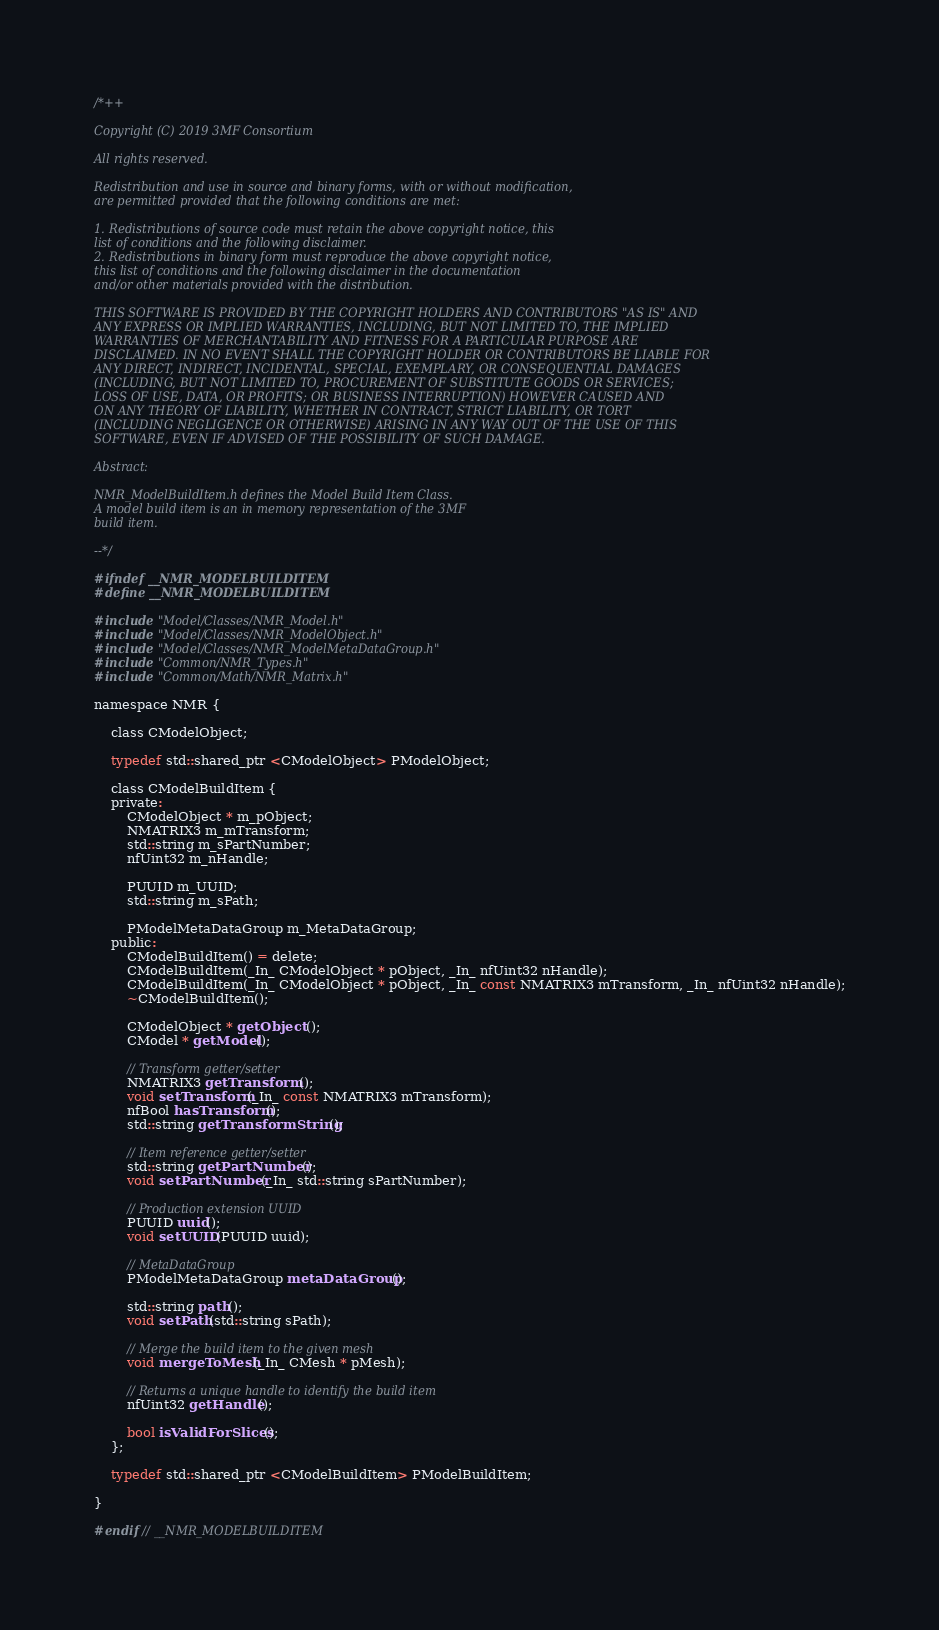<code> <loc_0><loc_0><loc_500><loc_500><_C_>/*++

Copyright (C) 2019 3MF Consortium

All rights reserved.

Redistribution and use in source and binary forms, with or without modification,
are permitted provided that the following conditions are met:

1. Redistributions of source code must retain the above copyright notice, this
list of conditions and the following disclaimer.
2. Redistributions in binary form must reproduce the above copyright notice,
this list of conditions and the following disclaimer in the documentation
and/or other materials provided with the distribution.

THIS SOFTWARE IS PROVIDED BY THE COPYRIGHT HOLDERS AND CONTRIBUTORS "AS IS" AND
ANY EXPRESS OR IMPLIED WARRANTIES, INCLUDING, BUT NOT LIMITED TO, THE IMPLIED
WARRANTIES OF MERCHANTABILITY AND FITNESS FOR A PARTICULAR PURPOSE ARE
DISCLAIMED. IN NO EVENT SHALL THE COPYRIGHT HOLDER OR CONTRIBUTORS BE LIABLE FOR
ANY DIRECT, INDIRECT, INCIDENTAL, SPECIAL, EXEMPLARY, OR CONSEQUENTIAL DAMAGES
(INCLUDING, BUT NOT LIMITED TO, PROCUREMENT OF SUBSTITUTE GOODS OR SERVICES;
LOSS OF USE, DATA, OR PROFITS; OR BUSINESS INTERRUPTION) HOWEVER CAUSED AND
ON ANY THEORY OF LIABILITY, WHETHER IN CONTRACT, STRICT LIABILITY, OR TORT
(INCLUDING NEGLIGENCE OR OTHERWISE) ARISING IN ANY WAY OUT OF THE USE OF THIS
SOFTWARE, EVEN IF ADVISED OF THE POSSIBILITY OF SUCH DAMAGE.

Abstract:

NMR_ModelBuildItem.h defines the Model Build Item Class.
A model build item is an in memory representation of the 3MF
build item.

--*/

#ifndef __NMR_MODELBUILDITEM
#define __NMR_MODELBUILDITEM

#include "Model/Classes/NMR_Model.h" 
#include "Model/Classes/NMR_ModelObject.h" 
#include "Model/Classes/NMR_ModelMetaDataGroup.h" 
#include "Common/NMR_Types.h" 
#include "Common/Math/NMR_Matrix.h" 

namespace NMR {

	class CModelObject;
	
	typedef std::shared_ptr <CModelObject> PModelObject;

	class CModelBuildItem {
	private:
		CModelObject * m_pObject;
		NMATRIX3 m_mTransform;
		std::string m_sPartNumber;
		nfUint32 m_nHandle;
		
		PUUID m_UUID;
		std::string m_sPath;

		PModelMetaDataGroup m_MetaDataGroup;
	public:
		CModelBuildItem() = delete;
		CModelBuildItem(_In_ CModelObject * pObject, _In_ nfUint32 nHandle);
		CModelBuildItem(_In_ CModelObject * pObject, _In_ const NMATRIX3 mTransform, _In_ nfUint32 nHandle);
		~CModelBuildItem();
		
		CModelObject * getObject ();
		CModel * getModel();

		// Transform getter/setter
		NMATRIX3 getTransform ();
		void setTransform(_In_ const NMATRIX3 mTransform);
		nfBool hasTransform();
		std::string getTransformString();

		// Item reference getter/setter
		std::string getPartNumber();
		void setPartNumber(_In_ std::string sPartNumber);

		// Production extension UUID
		PUUID uuid();
		void setUUID(PUUID uuid);

		// MetaDataGroup
		PModelMetaDataGroup metaDataGroup();

		std::string path();
		void setPath(std::string sPath);

		// Merge the build item to the given mesh
		void mergeToMesh(_In_ CMesh * pMesh);

		// Returns a unique handle to identify the build item
		nfUint32 getHandle();

		bool isValidForSlices();
	};

	typedef std::shared_ptr <CModelBuildItem> PModelBuildItem;

}

#endif // __NMR_MODELBUILDITEM
</code> 